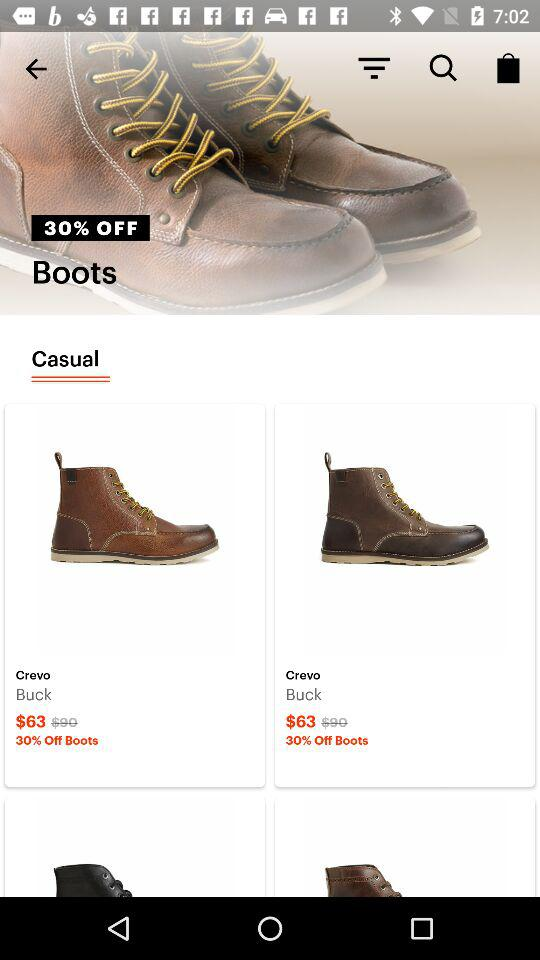What is the price of "Crevo" before the discount? The price of "Crevo" before the discount is $90. 